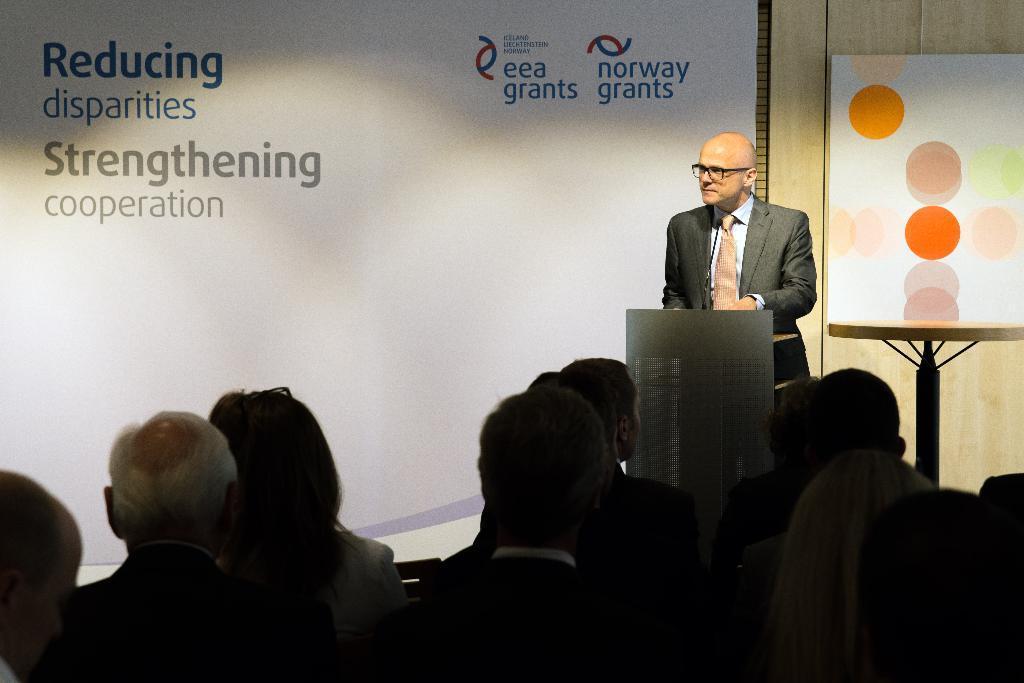Can you describe this image briefly? It looks like a seminar, there is a man standing in the front and in front of him many people were sitting and beside the man there is a table and there are are two banners behind the man, the first one is regarding the organisation and the second one is a simple painting and in the background there is a wooden wall. 